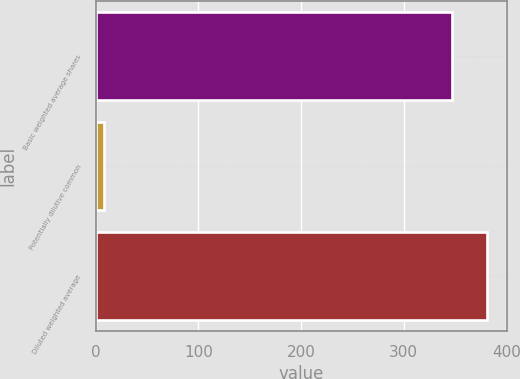<chart> <loc_0><loc_0><loc_500><loc_500><bar_chart><fcel>Basic weighted average shares<fcel>Potentially dilutive common<fcel>Diluted weighted average<nl><fcel>347<fcel>8<fcel>381.7<nl></chart> 